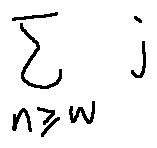<formula> <loc_0><loc_0><loc_500><loc_500>\sum \lim i t s _ { n \geq w } j</formula> 